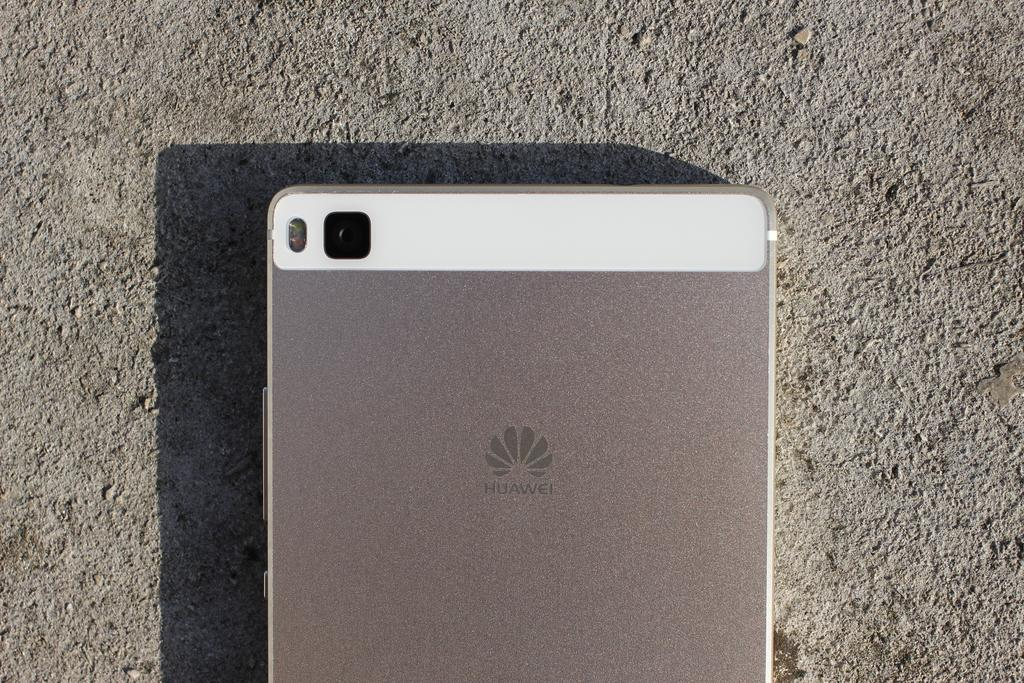<image>
Render a clear and concise summary of the photo. the back of a Huawei cell phone on a sandy surface 